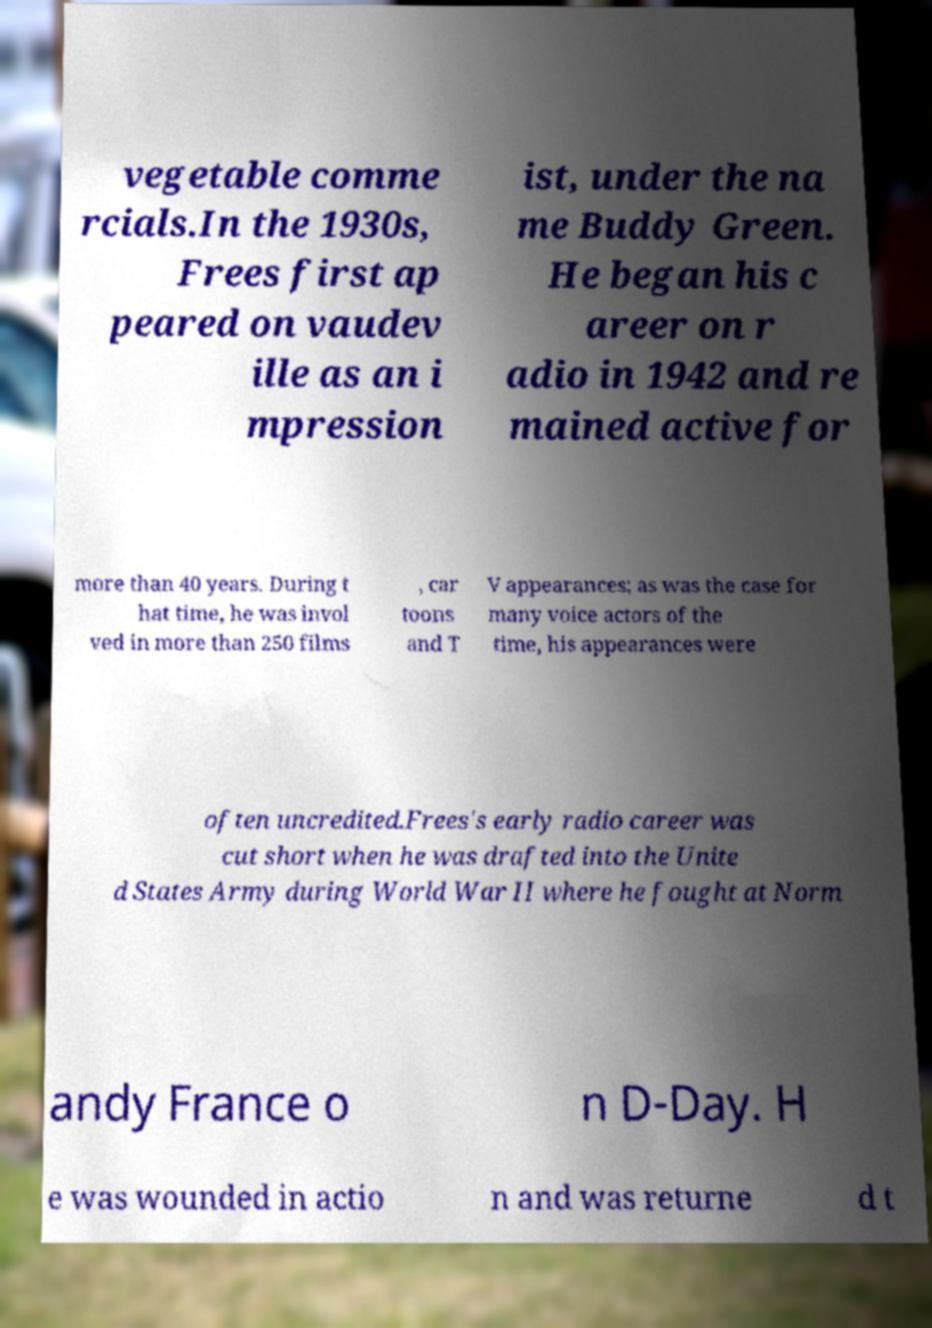Could you assist in decoding the text presented in this image and type it out clearly? vegetable comme rcials.In the 1930s, Frees first ap peared on vaudev ille as an i mpression ist, under the na me Buddy Green. He began his c areer on r adio in 1942 and re mained active for more than 40 years. During t hat time, he was invol ved in more than 250 films , car toons and T V appearances; as was the case for many voice actors of the time, his appearances were often uncredited.Frees's early radio career was cut short when he was drafted into the Unite d States Army during World War II where he fought at Norm andy France o n D-Day. H e was wounded in actio n and was returne d t 